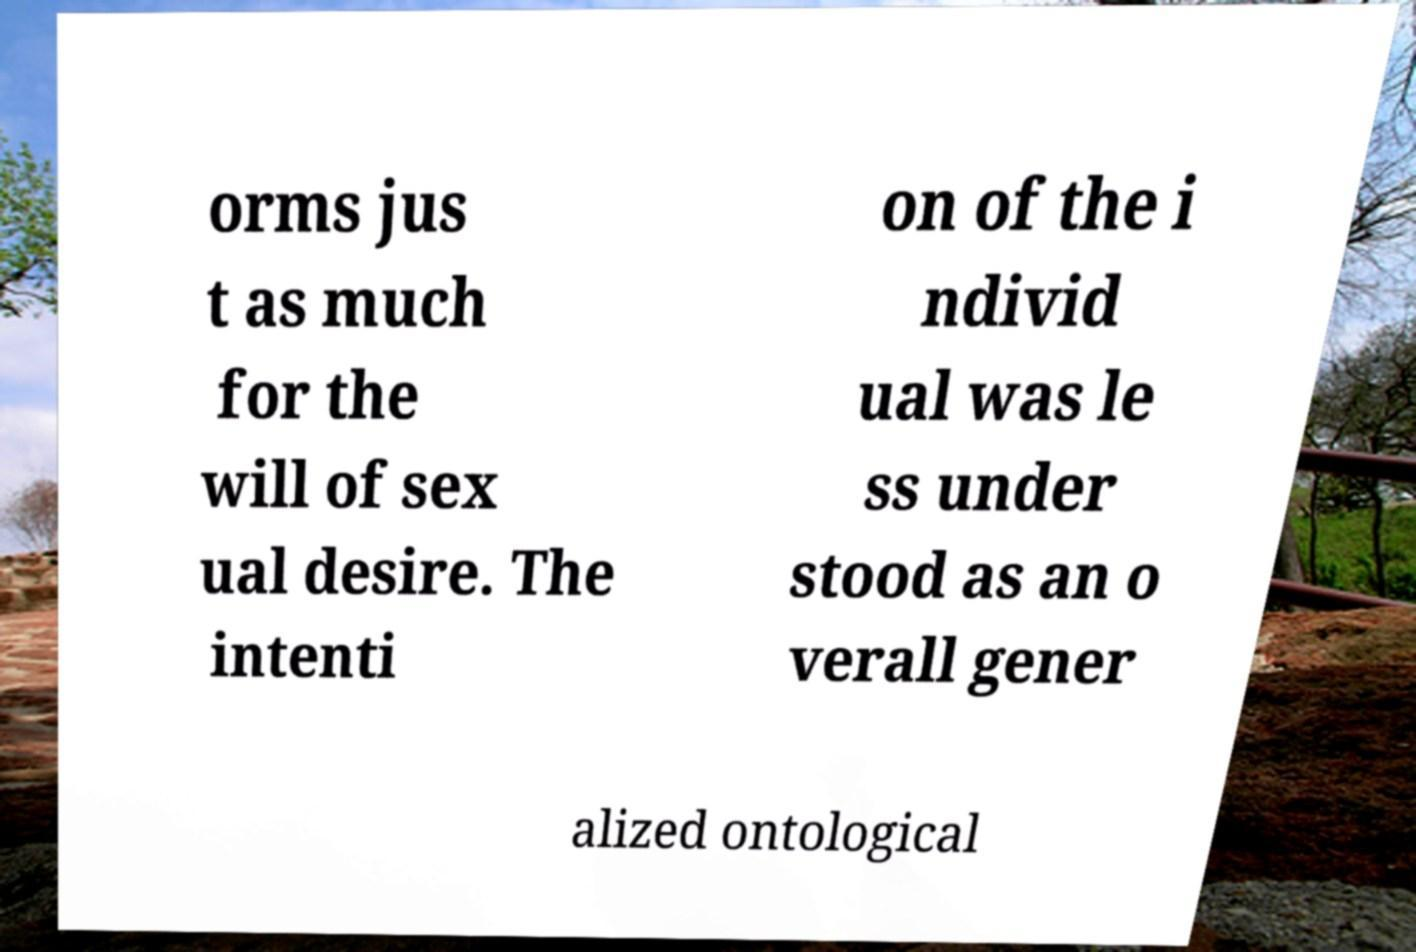Please identify and transcribe the text found in this image. orms jus t as much for the will of sex ual desire. The intenti on of the i ndivid ual was le ss under stood as an o verall gener alized ontological 